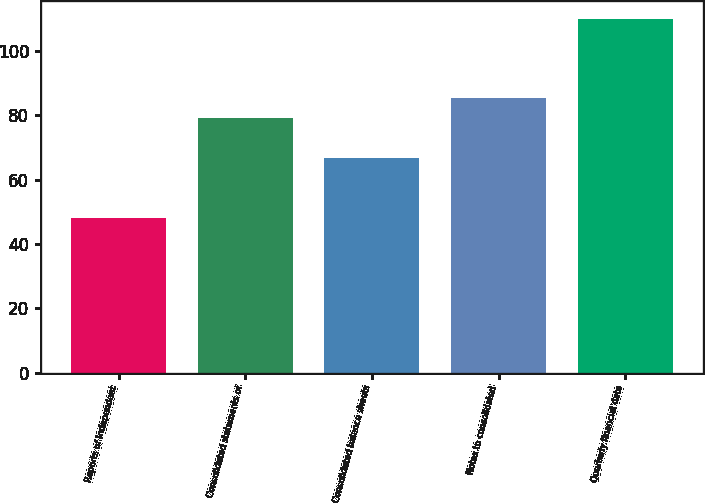Convert chart to OTSL. <chart><loc_0><loc_0><loc_500><loc_500><bar_chart><fcel>Reports of Independent<fcel>Consolidated statements of<fcel>Consolidated balance sheets<fcel>Notes to consolidated<fcel>Quarterly financial data<nl><fcel>48<fcel>79<fcel>66.6<fcel>85.2<fcel>110<nl></chart> 